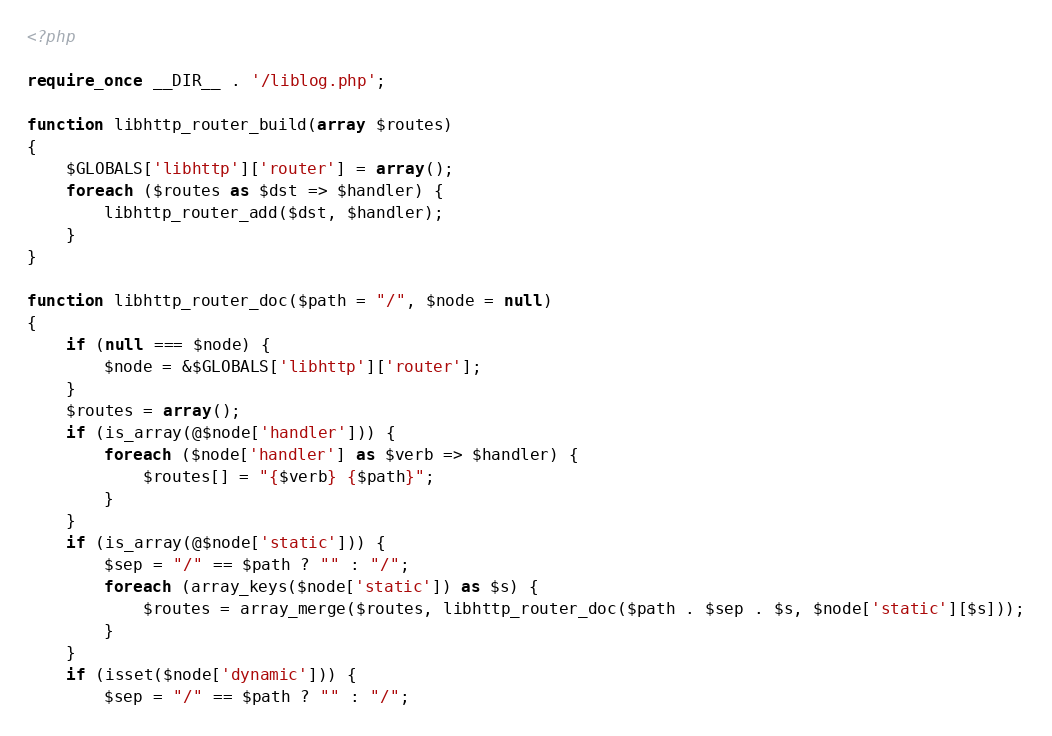<code> <loc_0><loc_0><loc_500><loc_500><_PHP_><?php

require_once __DIR__ . '/liblog.php';

function libhttp_router_build(array $routes)
{
    $GLOBALS['libhttp']['router'] = array();
    foreach ($routes as $dst => $handler) {
        libhttp_router_add($dst, $handler);
    }
}

function libhttp_router_doc($path = "/", $node = null)
{
    if (null === $node) {
        $node = &$GLOBALS['libhttp']['router'];
    }
    $routes = array();
    if (is_array(@$node['handler'])) {
        foreach ($node['handler'] as $verb => $handler) {
            $routes[] = "{$verb} {$path}";
        }
    }
    if (is_array(@$node['static'])) {
        $sep = "/" == $path ? "" : "/";
        foreach (array_keys($node['static']) as $s) {
            $routes = array_merge($routes, libhttp_router_doc($path . $sep . $s, $node['static'][$s]));
        }
    }
    if (isset($node['dynamic'])) {
        $sep = "/" == $path ? "" : "/";</code> 